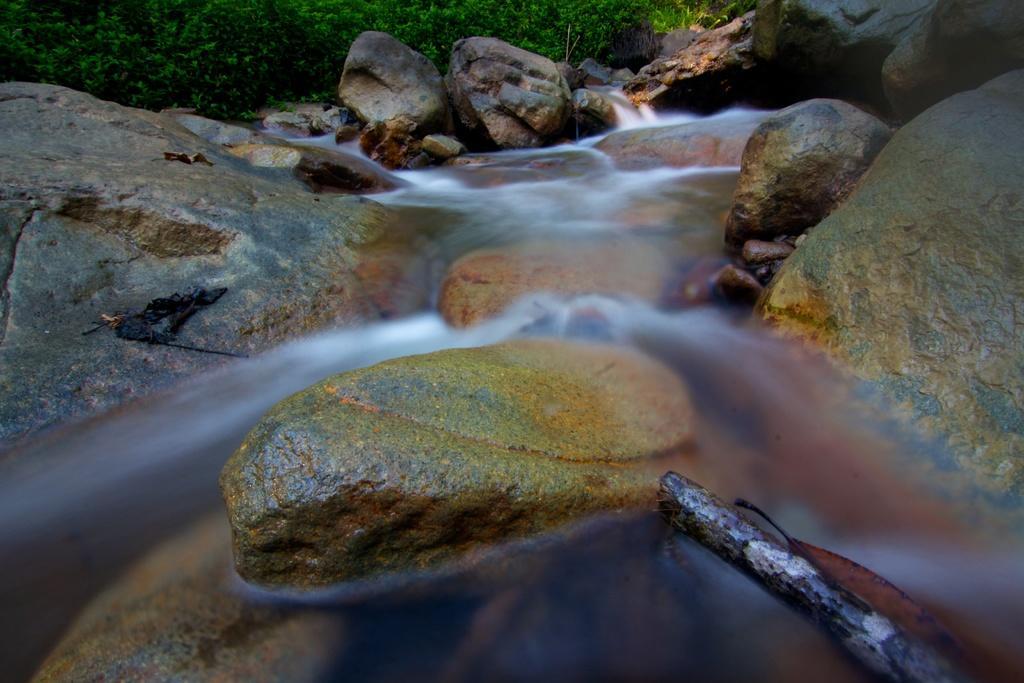Describe this image in one or two sentences. In the image I can see a water fall on the rocks and behind there are some rocks. 